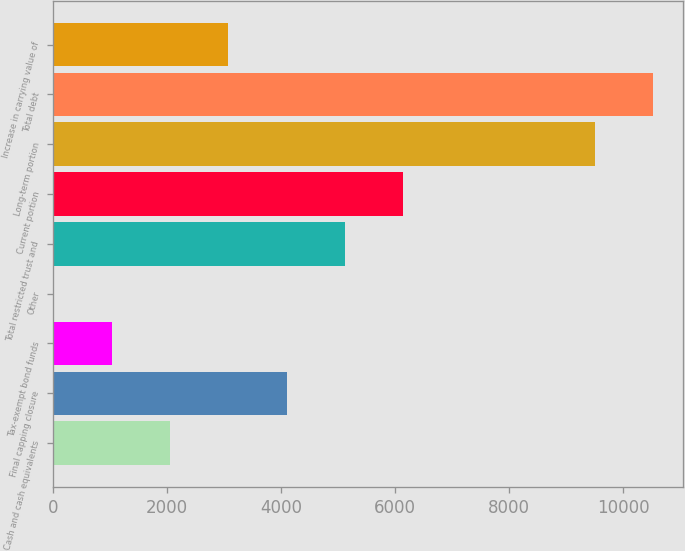<chart> <loc_0><loc_0><loc_500><loc_500><bar_chart><fcel>Cash and cash equivalents<fcel>Final capping closure<fcel>Tax-exempt bond funds<fcel>Other<fcel>Total restricted trust and<fcel>Current portion<fcel>Long-term portion<fcel>Total debt<fcel>Increase in carrying value of<nl><fcel>2057.2<fcel>4099.4<fcel>1036.1<fcel>15<fcel>5120.5<fcel>6141.6<fcel>9500<fcel>10521.1<fcel>3078.3<nl></chart> 